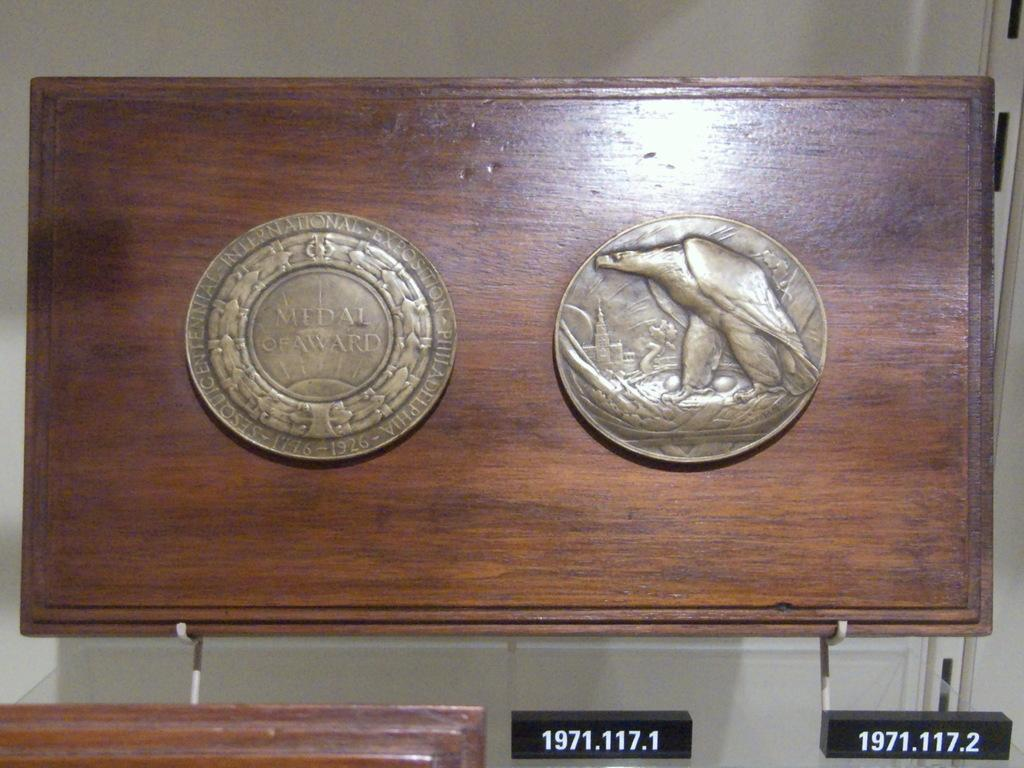<image>
Write a terse but informative summary of the picture. Two coins are mounted on a piece of wood with numbers 1971.117.1 on a black tag. 